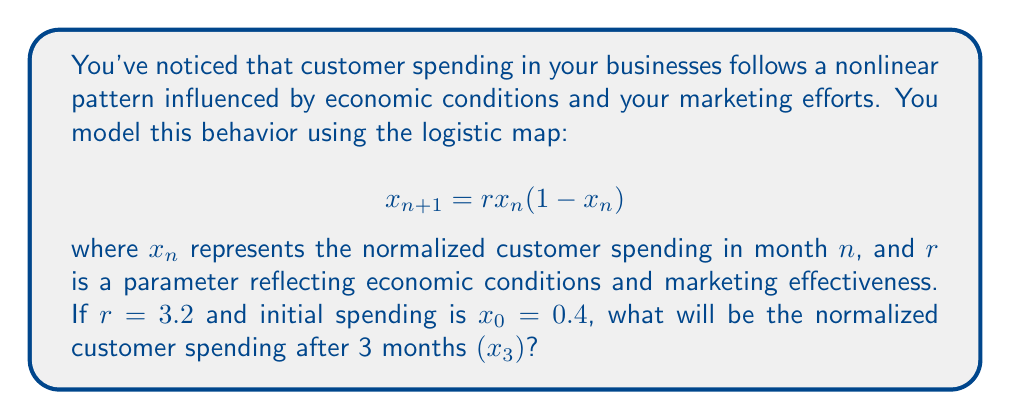Solve this math problem. To solve this problem, we need to iterate the logistic map equation three times:

1. Calculate $x_1$:
   $$x_1 = r \cdot x_0 \cdot (1-x_0) = 3.2 \cdot 0.4 \cdot (1-0.4) = 3.2 \cdot 0.4 \cdot 0.6 = 0.768$$

2. Calculate $x_2$:
   $$x_2 = r \cdot x_1 \cdot (1-x_1) = 3.2 \cdot 0.768 \cdot (1-0.768) = 3.2 \cdot 0.768 \cdot 0.232 = 0.570777$$

3. Calculate $x_3$:
   $$x_3 = r \cdot x_2 \cdot (1-x_2) = 3.2 \cdot 0.570777 \cdot (1-0.570777) = 3.2 \cdot 0.570777 \cdot 0.429223 = 0.784155$$

Therefore, the normalized customer spending after 3 months $(x_3)$ is approximately 0.784155.
Answer: 0.784155 